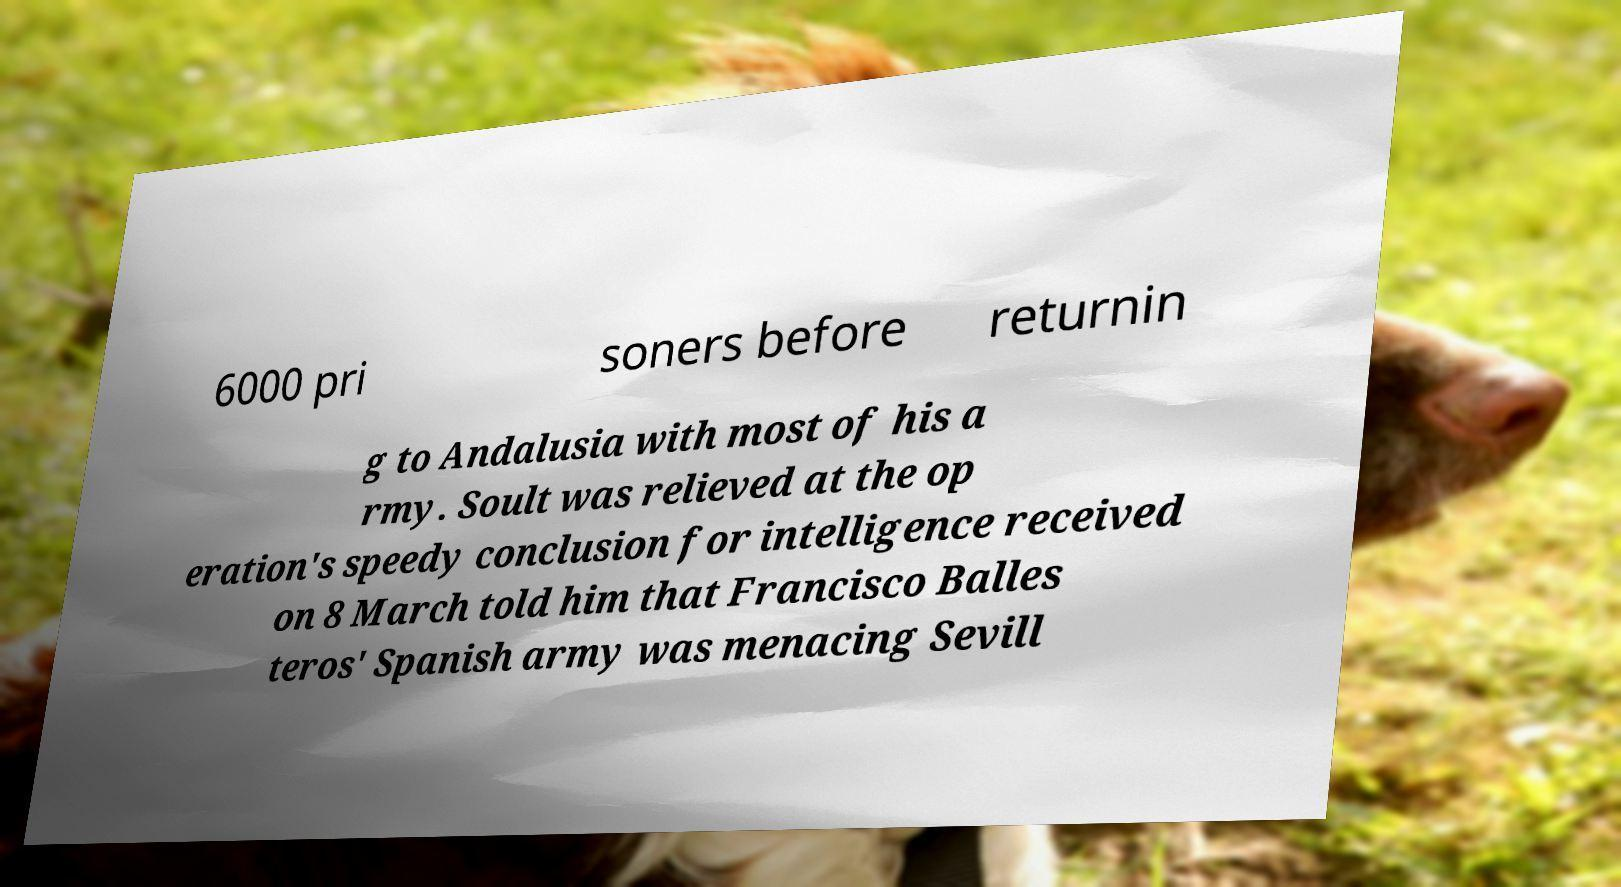Could you extract and type out the text from this image? 6000 pri soners before returnin g to Andalusia with most of his a rmy. Soult was relieved at the op eration's speedy conclusion for intelligence received on 8 March told him that Francisco Balles teros' Spanish army was menacing Sevill 